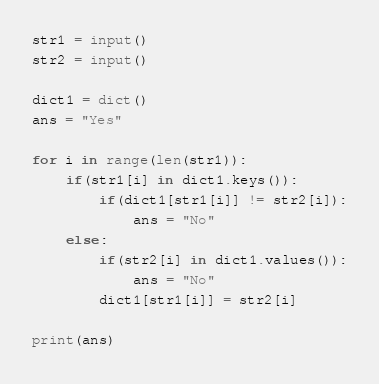<code> <loc_0><loc_0><loc_500><loc_500><_Python_>str1 = input()
str2 = input()

dict1 = dict()
ans = "Yes"

for i in range(len(str1)):
    if(str1[i] in dict1.keys()):
        if(dict1[str1[i]] != str2[i]):
            ans = "No"
    else:
        if(str2[i] in dict1.values()):
            ans = "No"
        dict1[str1[i]] = str2[i]

print(ans)
</code> 